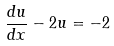Convert formula to latex. <formula><loc_0><loc_0><loc_500><loc_500>\frac { d u } { d x } - 2 u = - 2</formula> 